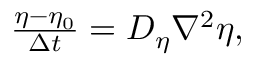<formula> <loc_0><loc_0><loc_500><loc_500>\begin{array} { r } { \frac { \eta - \eta _ { 0 } } { \Delta t } = D _ { \eta } \nabla ^ { 2 } \eta , } \end{array}</formula> 